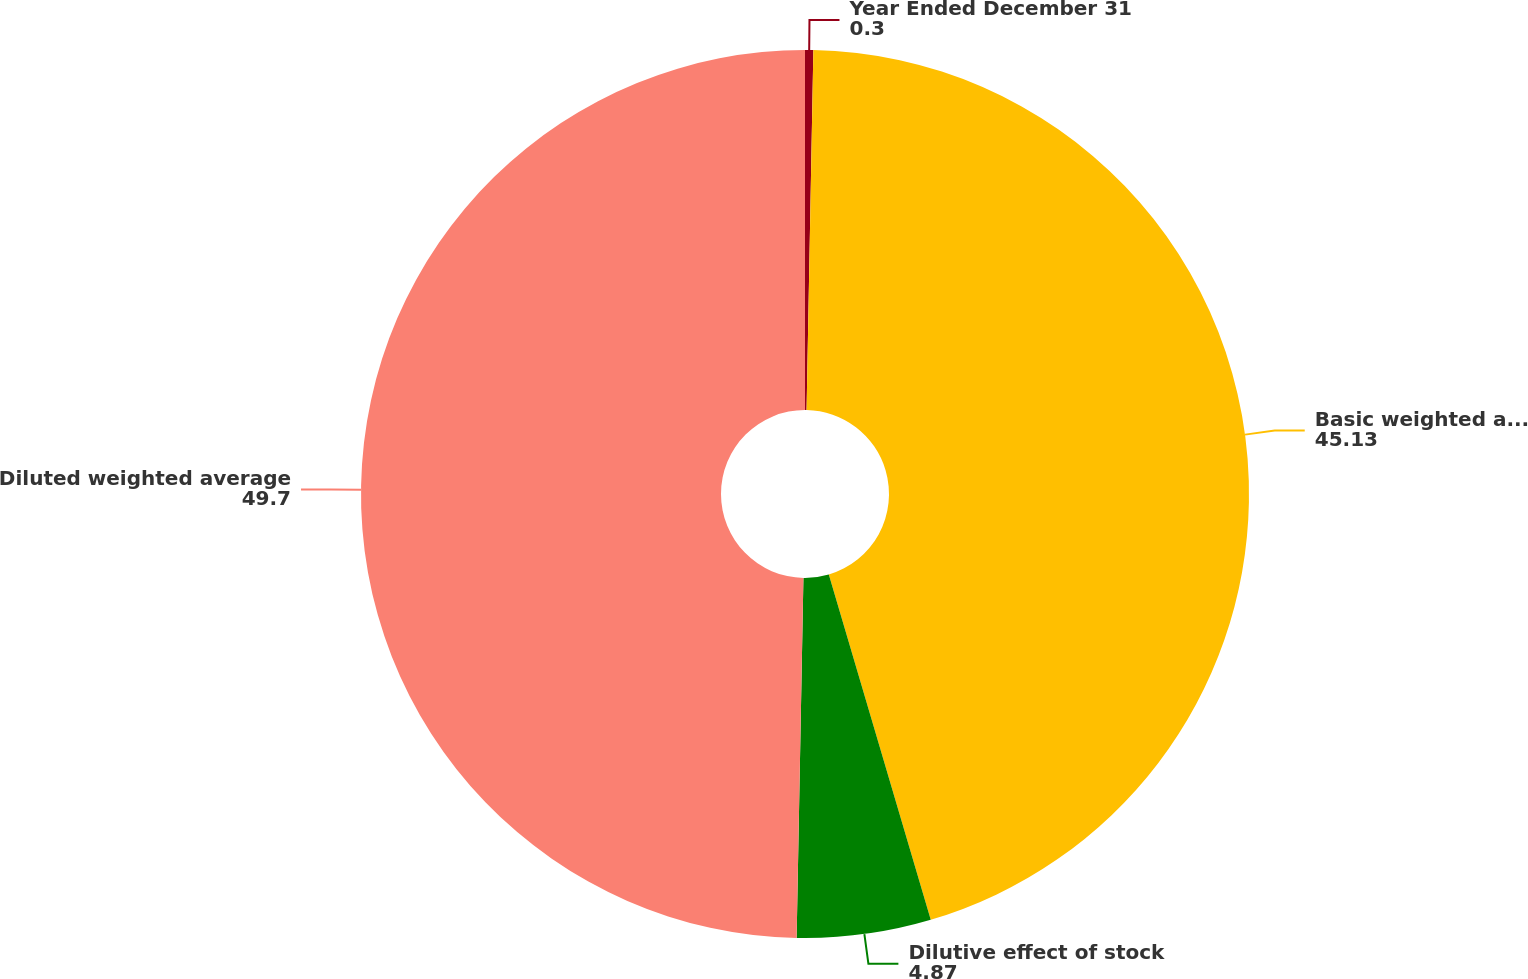Convert chart. <chart><loc_0><loc_0><loc_500><loc_500><pie_chart><fcel>Year Ended December 31<fcel>Basic weighted average shares<fcel>Dilutive effect of stock<fcel>Diluted weighted average<nl><fcel>0.3%<fcel>45.13%<fcel>4.87%<fcel>49.7%<nl></chart> 